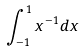<formula> <loc_0><loc_0><loc_500><loc_500>\int _ { - 1 } ^ { 1 } x ^ { - 1 } d x</formula> 